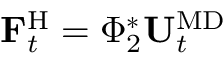Convert formula to latex. <formula><loc_0><loc_0><loc_500><loc_500>F _ { t } ^ { H } = \Phi _ { 2 } ^ { * } U _ { t } ^ { M D }</formula> 